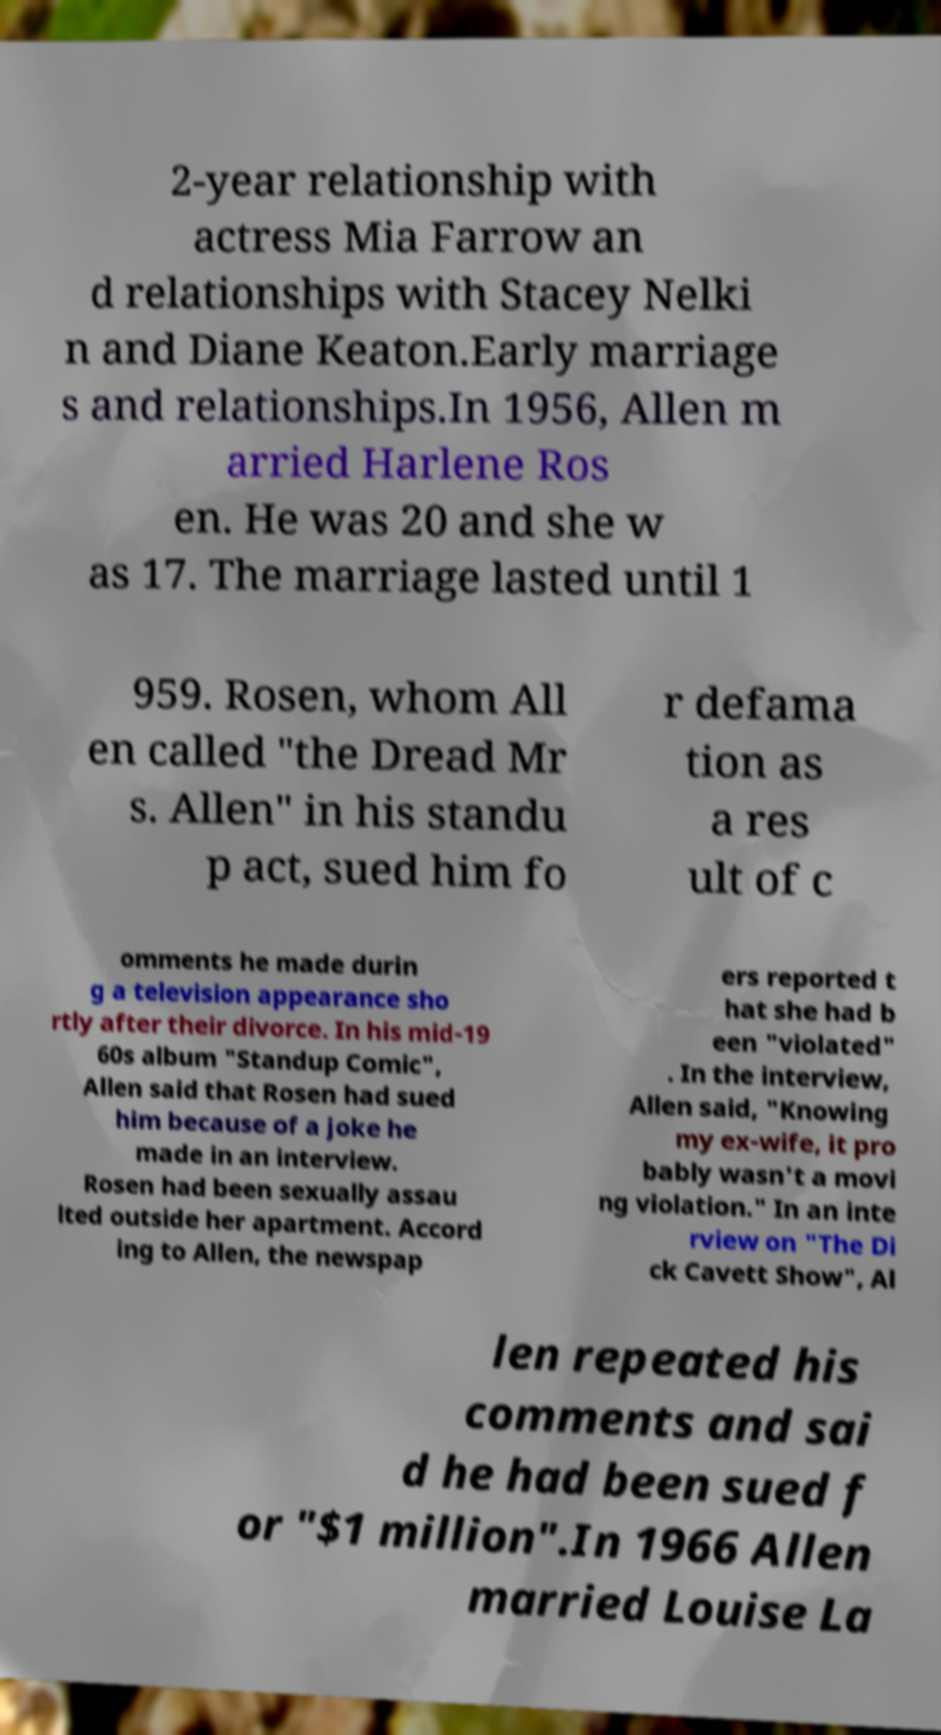There's text embedded in this image that I need extracted. Can you transcribe it verbatim? 2-year relationship with actress Mia Farrow an d relationships with Stacey Nelki n and Diane Keaton.Early marriage s and relationships.In 1956, Allen m arried Harlene Ros en. He was 20 and she w as 17. The marriage lasted until 1 959. Rosen, whom All en called "the Dread Mr s. Allen" in his standu p act, sued him fo r defama tion as a res ult of c omments he made durin g a television appearance sho rtly after their divorce. In his mid-19 60s album "Standup Comic", Allen said that Rosen had sued him because of a joke he made in an interview. Rosen had been sexually assau lted outside her apartment. Accord ing to Allen, the newspap ers reported t hat she had b een "violated" . In the interview, Allen said, "Knowing my ex-wife, it pro bably wasn't a movi ng violation." In an inte rview on "The Di ck Cavett Show", Al len repeated his comments and sai d he had been sued f or "$1 million".In 1966 Allen married Louise La 